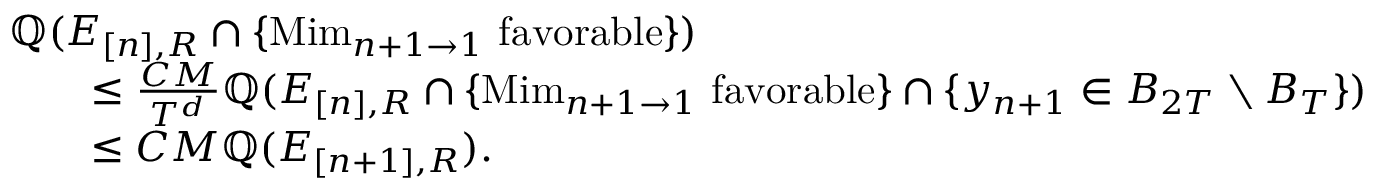Convert formula to latex. <formula><loc_0><loc_0><loc_500><loc_500>\begin{array} { r l } { { \mathbb { Q } ( E _ { [ n ] , R } \cap \{ M i m _ { n + 1 \to 1 } f a v o r a b l e \} ) } \quad } \\ & { \leq \frac { C M } { T ^ { d } } \mathbb { Q } ( E _ { [ n ] , R } \cap \{ M i m _ { n + 1 \to 1 } f a v o r a b l e \} \cap \{ y _ { n + 1 } \in B _ { 2 T } \ B _ { T } \} ) } \\ & { \leq C M \mathbb { Q } ( E _ { [ n + 1 ] , R } ) . } \end{array}</formula> 